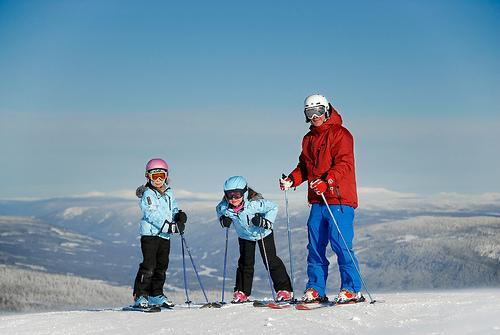Can you identify any specific color theme in the attire of the people in the image? They are wearing a combination of red, blue, black, and pink, with black pants, red and blue jackets, pink and blue helmets, and various colored ski boots and goggles. What type of head accessories are the people wearing in the image? They are wearing various helmets and goggles, including a pink helmet, a blue helmet, a white helmet, black goggles, and yellow framed goggles. What type of outerwear is the adult wearing, and what is the main color? The adult is wearing a red coat and blue pants, possibly with a red and white glove. Are any children in the image wearing goggles? If so, describe them. Yes, there are yellow framed goggles on a little girl in the image. How many people are skiing in the image, and what is their presumed relationship? There are three people skiing in the image, likely to be a family with an adult and two children. Identify and describe any ski equipment that is visible in the foreground of the image. Visible ski equipment includes pink and blue ski boots on skis, blue ski poles that the girl is using, and blue, black, and pink helmets on the heads of the individuals. Mention any unique features in the background of the image. There is a very blue and clear sky above the mountains in the background, enhancing the beauty of the scene. What commonality can be found in the jackets of the people in the image? They both have red and blue jackets, with the adult wearing a red jacket and the girl wearing a blue one. Describe the activity that the people are engaged in within the image. They are skiing as a family on a snowy mountain, and some of them are leaning forward and bending over while skiing. Are the goggles worn by the little girl with orange frames at coordinates X:145 Y:169? The goggles have yellow frames, not orange. The instruction is misleading by providing the wrong color of the goggles' frame.  Is the green helmet on the girl at coordinates X:221 Y:174? The helmet is actually blue, not green. The instruction is misleading in terms of color. Can you find the man wearing a purple coat at coordinates X:295 Y:101? The man is actually wearing a red coat, not a purple one. The instruction is misleading with respect to the color of the coat. Can you spot the little girl wearing brown pants at coordinates X:137 Y:229? The little girl is actually wearing black pants, not brown. The instruction is misleading with respect to the color of the pants. Is the adult wearing a black helmet at coordinates X:300 Y:91? The adult is actually wearing a white helmet, not a black one. The instruction is misleading in terms of helmet color. Are there two boys skiing at coordinates X:113 Y:150? The skiers are actually two girls, not boys. The instruction is misleading regarding the gender of the skiers. 